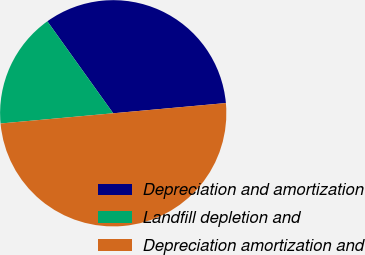Convert chart to OTSL. <chart><loc_0><loc_0><loc_500><loc_500><pie_chart><fcel>Depreciation and amortization<fcel>Landfill depletion and<fcel>Depreciation amortization and<nl><fcel>33.45%<fcel>16.55%<fcel>50.0%<nl></chart> 